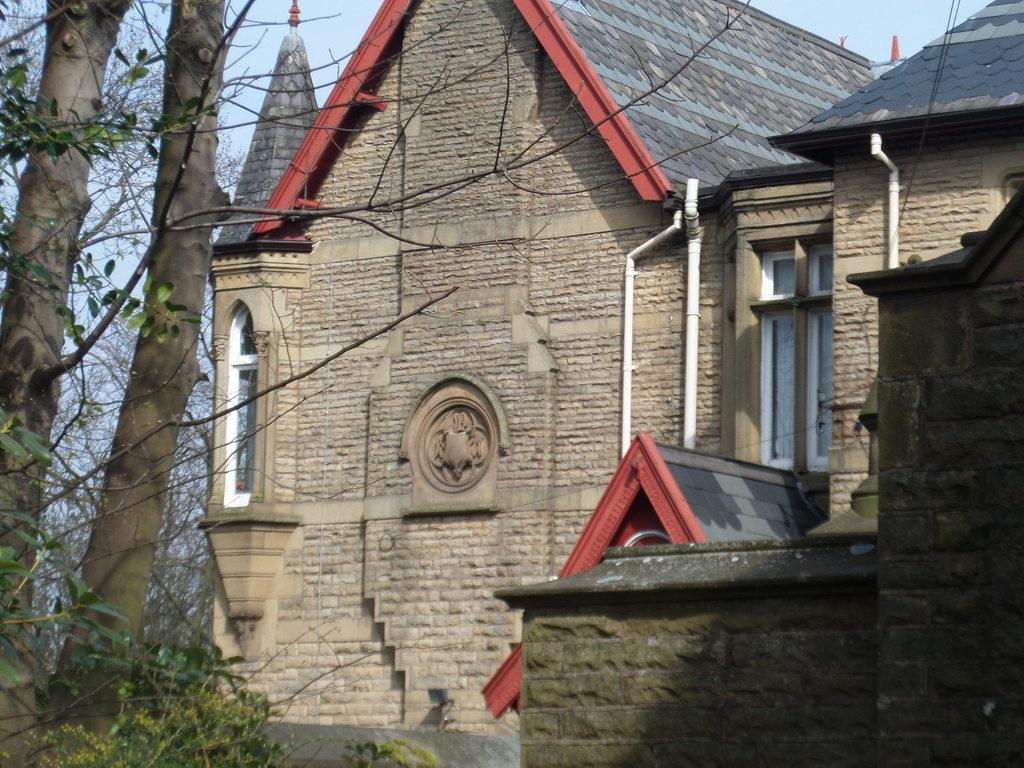What type of structure is visible in the image? There is a stone wall and stone buildings in the image. What other elements can be seen in the image? Wires, pipes, trees, and the sky are visible in the image. Can you describe the vegetation in the image? There are trees in the image. What is visible in the background of the image? The sky is visible in the background of the image. How many geese are flying over the stone buildings in the image? There are no geese present in the image. Can you tell me what type of dinosaur is hiding behind the stone wall in the image? There are no dinosaurs present in the image. 